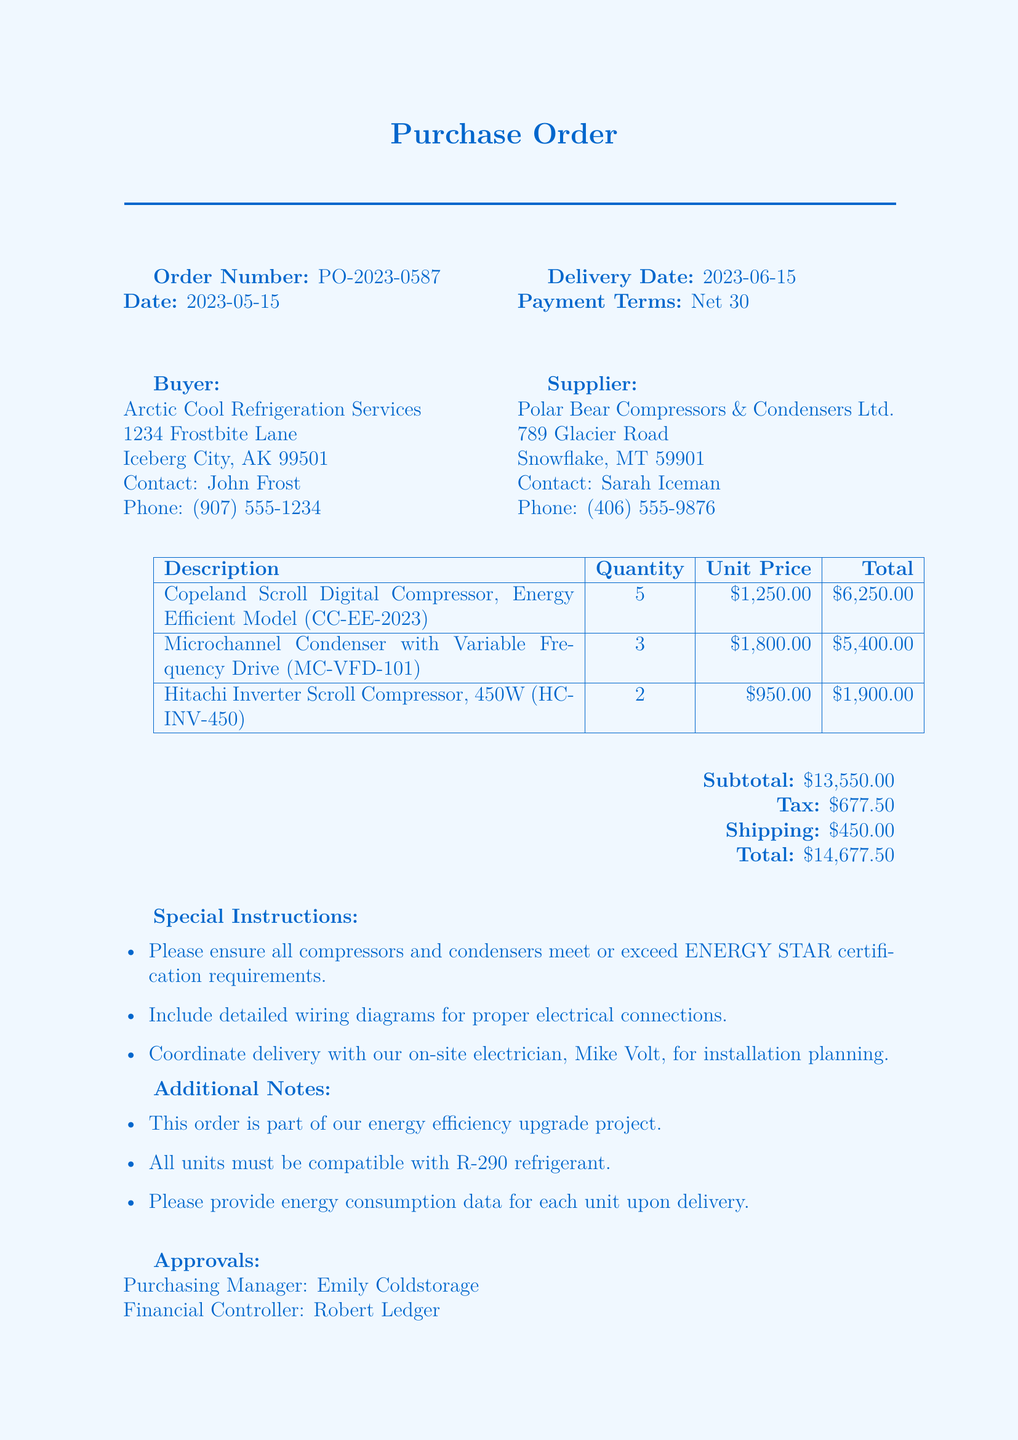What is the order number? The order number is explicitly stated in the document as a unique identifier for the transaction.
Answer: PO-2023-0587 Who is the buyer? The buyer's name and address are provided, representing the company making the purchase.
Answer: Arctic Cool Refrigeration Services What is the delivery date? The delivery date indicates when the purchased items are expected to arrive, as specified in the document.
Answer: 2023-06-15 What is the subtotal amount? The subtotal reflects the total cost of the items before taxes and shipping are added, as detailed in the financial section.
Answer: $13,550.00 How many units of the Copeland Scroll Compressor are ordered? The quantity of this specific item is listed in the items section, directly indicating how many units have been requested.
Answer: 5 What is a special instruction regarding the compressors and condensers? One of the special instructions emphasizes a requirement related to the products, indicating a standard they must meet.
Answer: ENERGY STAR certification requirements Who is responsible for coordinating delivery? Coordination details are provided in the special instructions, specifying a contact person for this purpose.
Answer: Mike Volt What are the payment terms listed in the document? The payment terms indicate the time frame within which payment should be made after receipt of the invoice.
Answer: Net 30 What is the total payment due for this purchase order? The total amount combines all costs, including items, tax, and shipping, clearly presented in the financial summary.
Answer: $14,677.50 